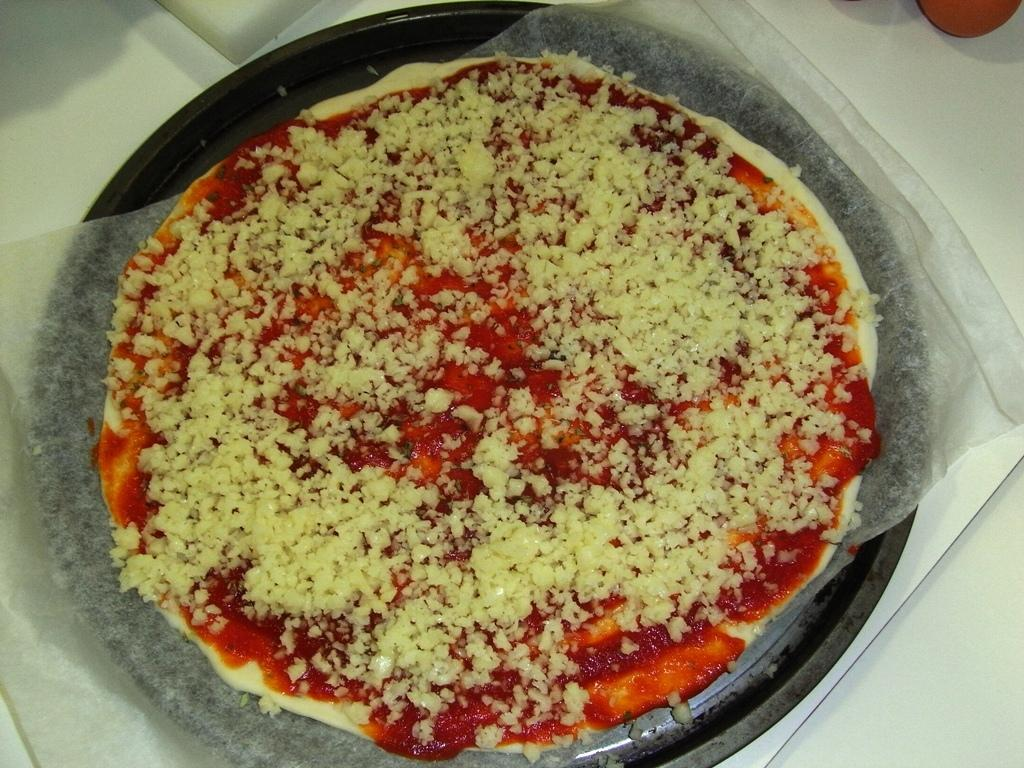What type of food is in the bowl in the image? The food in the bowl has cream and red colors. What color is the bowl? The bowl is black. What color is the surface the bowl is placed on? The bowl is on a white surface. How many zebras are visible in the image? There are no zebras present in the image. What type of hydrant is located next to the bowl? There is no hydrant present in the image. 